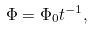Convert formula to latex. <formula><loc_0><loc_0><loc_500><loc_500>\Phi = \Phi _ { 0 } t ^ { - 1 } ,</formula> 